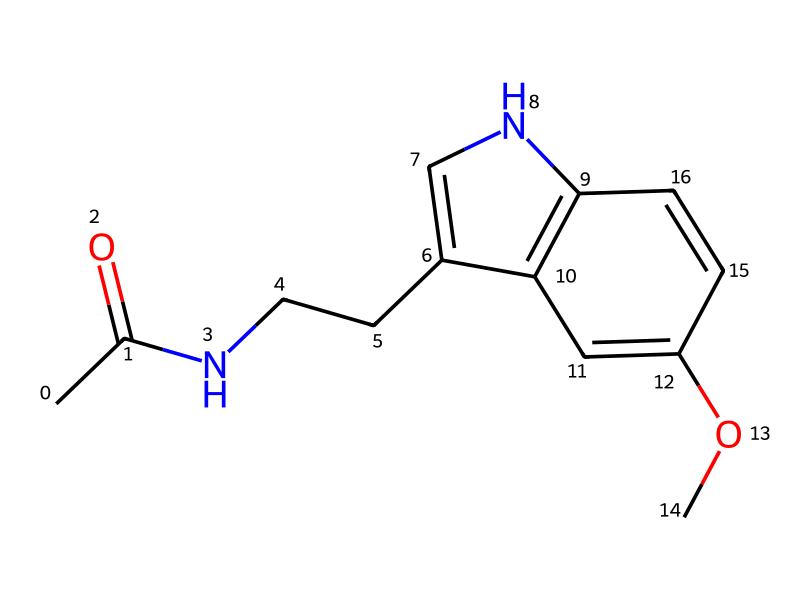What is the name of the chemical represented by this SMILES? The SMILES code corresponds to a specific molecular structure, which is melatonin, known for its role in regulating sleep cycles.
Answer: melatonin How many nitrogen atoms are present in this chemical? Analyzing the SMILES, we can count the nitrogen (N) symbols, of which there are two in the structure of melatonin.
Answer: two What type of functional group is primarily present in this chemical? The structure contains an amide group, indicated by the presence of a carbonyl (C=O) adjacent to a nitrogen (N), which is indicative of a primary amide.
Answer: amide How many carbon atoms are in the structure? By counting the carbon (C) symbols in the SMILES, we find there are 11 carbon atoms in the molecular structure of melatonin.
Answer: eleven Is there any presence of a methoxy group in this chemical? The chemical structure includes −OCH3, a methoxy group (−O−CH3), which is evident in the SMILES code showing an O connected to a carbon chain with three hydrogens.
Answer: yes What is the overall molecular formula of this chemical? By counting the atoms based on the SMILES representation, melatonin has the molecular formula C13H16N2O2.
Answer: C13H16N2O2 